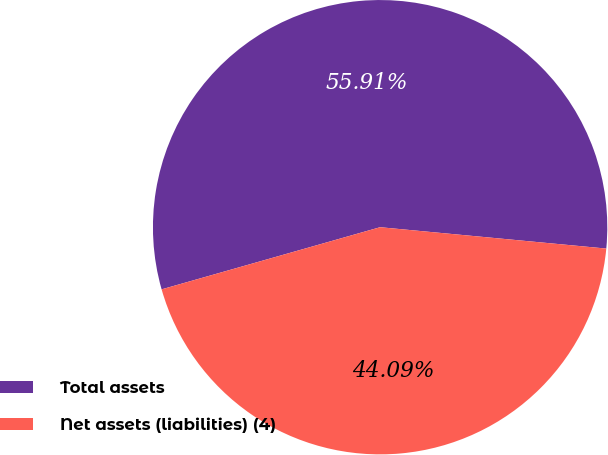Convert chart to OTSL. <chart><loc_0><loc_0><loc_500><loc_500><pie_chart><fcel>Total assets<fcel>Net assets (liabilities) (4)<nl><fcel>55.91%<fcel>44.09%<nl></chart> 